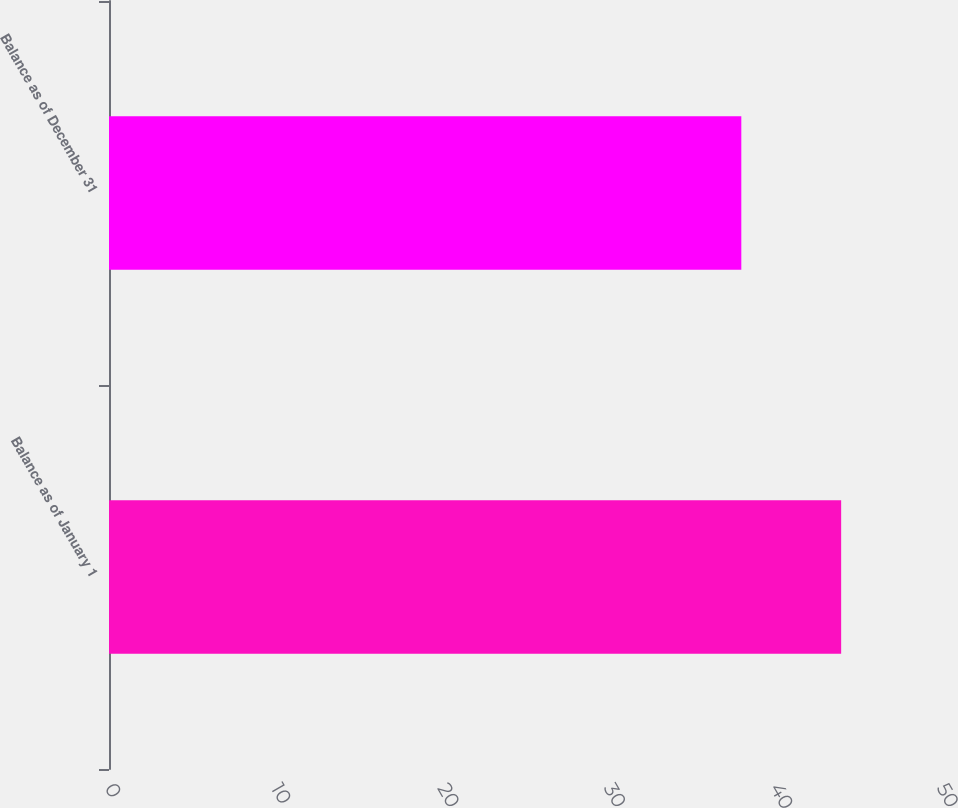Convert chart. <chart><loc_0><loc_0><loc_500><loc_500><bar_chart><fcel>Balance as of January 1<fcel>Balance as of December 31<nl><fcel>44<fcel>38<nl></chart> 